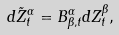Convert formula to latex. <formula><loc_0><loc_0><loc_500><loc_500>d \tilde { Z } ^ { \alpha } _ { t } = B ^ { \alpha } _ { \beta , t } d Z ^ { \beta } _ { t } ,</formula> 